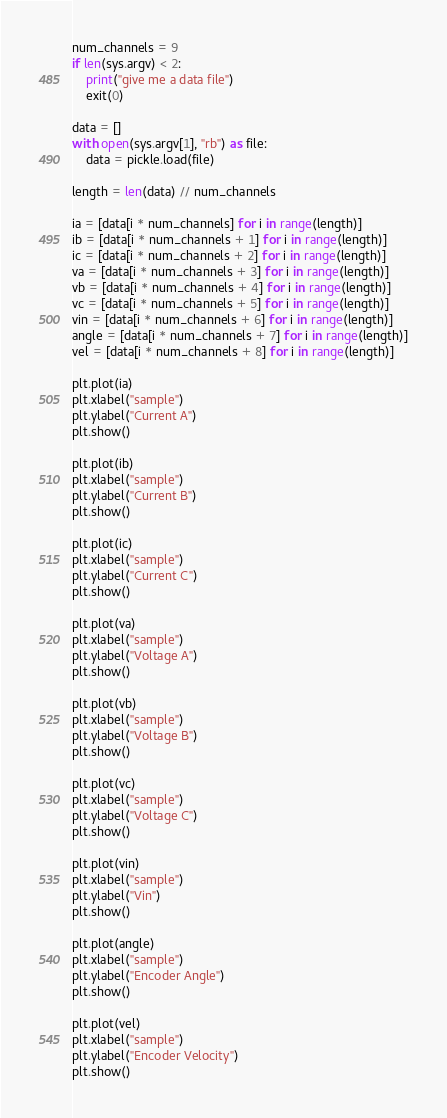Convert code to text. <code><loc_0><loc_0><loc_500><loc_500><_Python_>num_channels = 9
if len(sys.argv) < 2:
    print("give me a data file")
    exit(0)

data = []
with open(sys.argv[1], "rb") as file:
    data = pickle.load(file)

length = len(data) // num_channels

ia = [data[i * num_channels] for i in range(length)]
ib = [data[i * num_channels + 1] for i in range(length)]
ic = [data[i * num_channels + 2] for i in range(length)]
va = [data[i * num_channels + 3] for i in range(length)]
vb = [data[i * num_channels + 4] for i in range(length)]
vc = [data[i * num_channels + 5] for i in range(length)]
vin = [data[i * num_channels + 6] for i in range(length)]
angle = [data[i * num_channels + 7] for i in range(length)]
vel = [data[i * num_channels + 8] for i in range(length)]

plt.plot(ia)
plt.xlabel("sample")
plt.ylabel("Current A")
plt.show()

plt.plot(ib)
plt.xlabel("sample")
plt.ylabel("Current B")
plt.show()

plt.plot(ic)
plt.xlabel("sample")
plt.ylabel("Current C")
plt.show()

plt.plot(va)
plt.xlabel("sample")
plt.ylabel("Voltage A")
plt.show()

plt.plot(vb)
plt.xlabel("sample")
plt.ylabel("Voltage B")
plt.show()

plt.plot(vc)
plt.xlabel("sample")
plt.ylabel("Voltage C")
plt.show()

plt.plot(vin)
plt.xlabel("sample")
plt.ylabel("Vin")
plt.show()

plt.plot(angle)
plt.xlabel("sample")
plt.ylabel("Encoder Angle")
plt.show()

plt.plot(vel)
plt.xlabel("sample")
plt.ylabel("Encoder Velocity")
plt.show()
</code> 